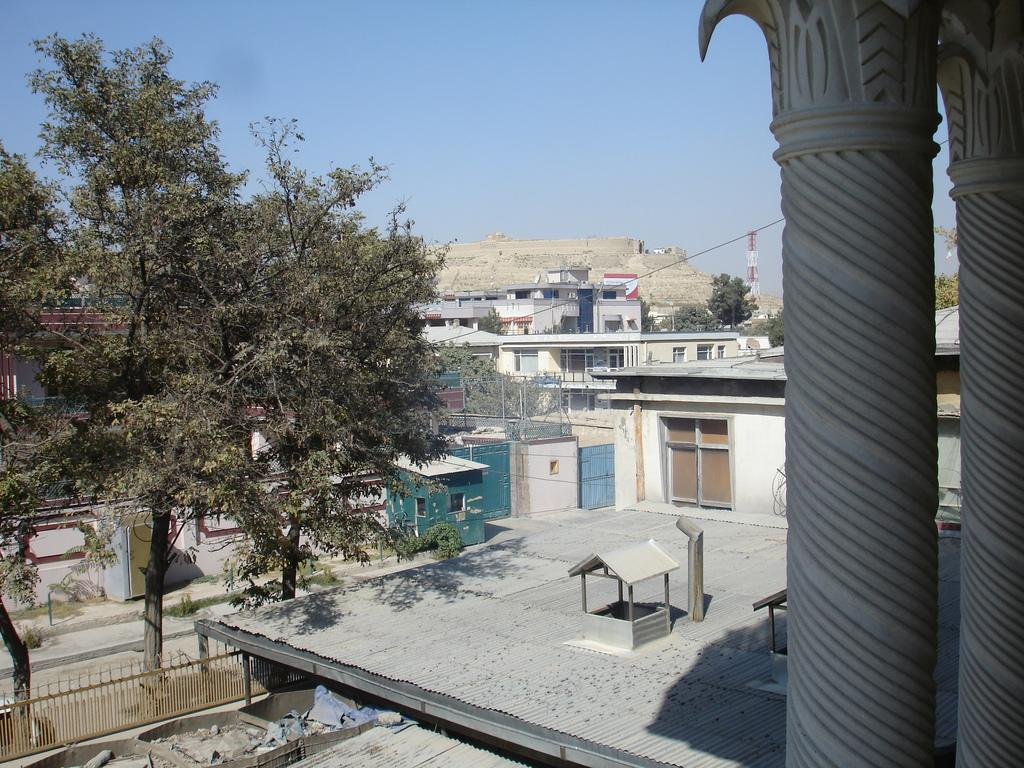What types of structures are visible in the image? There are many buildings in the image. What other elements can be seen in the image besides the buildings? There are trees in the image. What type of wire is being used by the girl in the image? There is no girl or wire present in the image. 